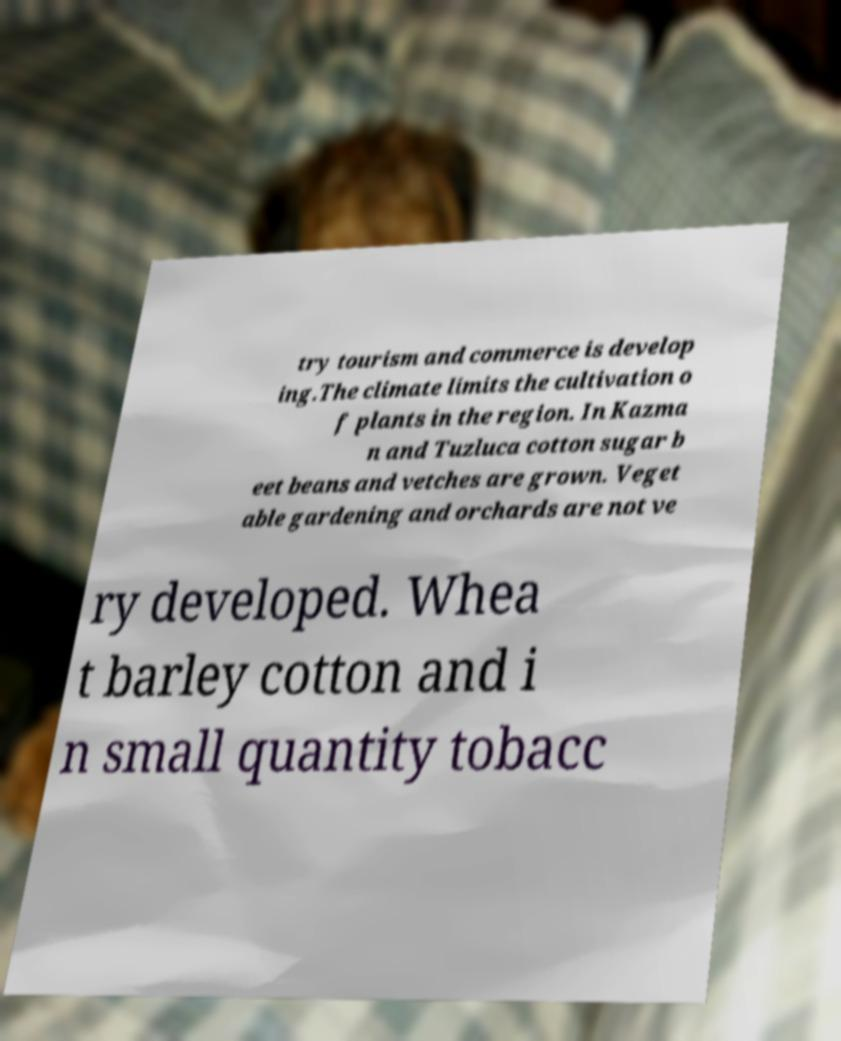Could you assist in decoding the text presented in this image and type it out clearly? try tourism and commerce is develop ing.The climate limits the cultivation o f plants in the region. In Kazma n and Tuzluca cotton sugar b eet beans and vetches are grown. Veget able gardening and orchards are not ve ry developed. Whea t barley cotton and i n small quantity tobacc 